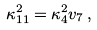<formula> <loc_0><loc_0><loc_500><loc_500>\kappa _ { 1 1 } ^ { 2 } = \kappa _ { 4 } ^ { 2 } v _ { 7 } \, ,</formula> 